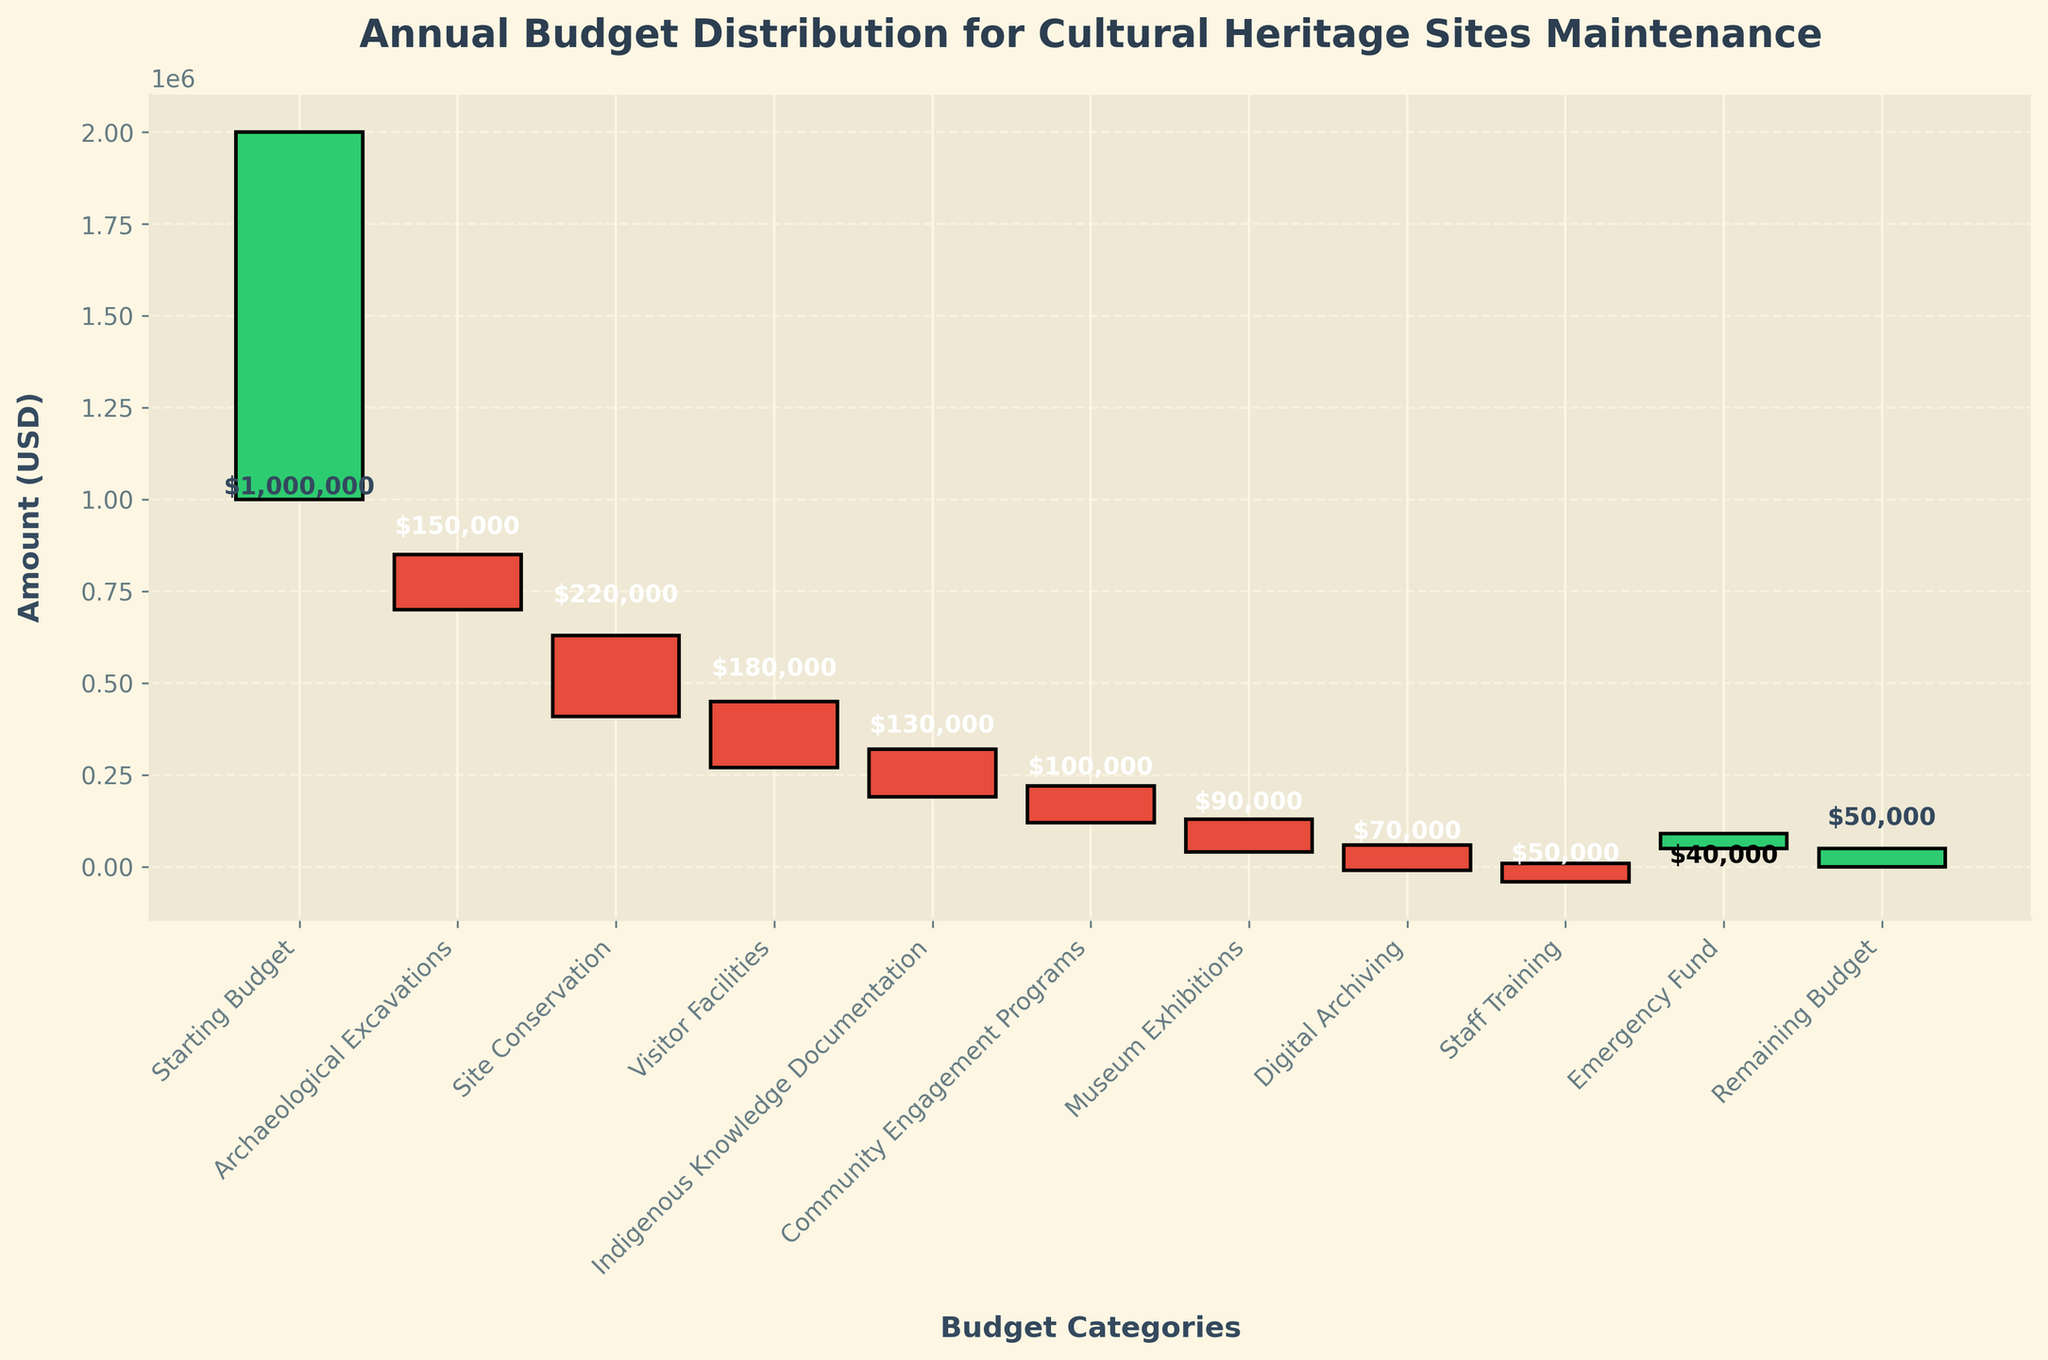What is the title of the chart? The title of the chart is located at the top and typically in larger, bold font to stand out. In this case, it is "Annual Budget Distribution for Cultural Heritage Sites Maintenance".
Answer: Annual Budget Distribution for Cultural Heritage Sites Maintenance What is the starting budget displayed in the chart? The starting budget is the first data point on the waterfall chart, labeled "Starting Budget". It indicates the initial amount of money available, which is $1,000,000.
Answer: $1,000,000 How much was allocated for Site Conservation? The allocation for Site Conservation is represented by a negative bar and labeled accordingly. The value for Site Conservation is $220,000.
Answer: $220,000 What is the remaining budget after all expenses and income? The remaining budget is the final data point on the chart, labeled "Remaining Budget". It shows the amount left after all expenses and income adjustments, which is $50,000.
Answer: $50,000 Which category received the least allocation? To determine the category with the least allocation, look for the smallest negative bar. "Staff Training" received the smallest allocation, which is $50,000.
Answer: Staff Training Which category had a positive impact on the budget? A category with a positive impact on the budget is represented by a positive bar. The "Emergency Fund" added $40,000 to the budget.
Answer: Emergency Fund What is the total amount spent on Archaeological Excavations, Site Conservation, and Visitor Facilities combined? Sum the absolute values of expenditures of these three categories: $150,000 (Archaeological Excavations) + $220,000 (Site Conservation) + $180,000 (Visitor Facilities) = $550,000.
Answer: $550,000 How much is the difference between the allocations for Indigenous Knowledge Documentation and Community Engagement Programs? Subtract the allocation for Community Engagement Programs from that for Indigenous Knowledge Documentation: $130,000 - $100,000 = $30,000.
Answer: $30,000 How does the allocation for Digital Archiving compare to that for Museum Exhibitions? Compare the absolute values of the allocations: Digital Archiving is $70,000, while Museum Exhibitions is $90,000. Digital Archiving received less than Museum Exhibitions.
Answer: Less What is the cumulative impact of the Emergency Fund on the remaining budget? The Emergency Fund is the only category with a positive value. Adding $40,000 to the final budget significantly reduces the deficit, culminating in a remaining budget of $50,000. This means the Emergency Fund contributed to turning a potential deficit into a remaining balance.
Answer: Significant positive impact 